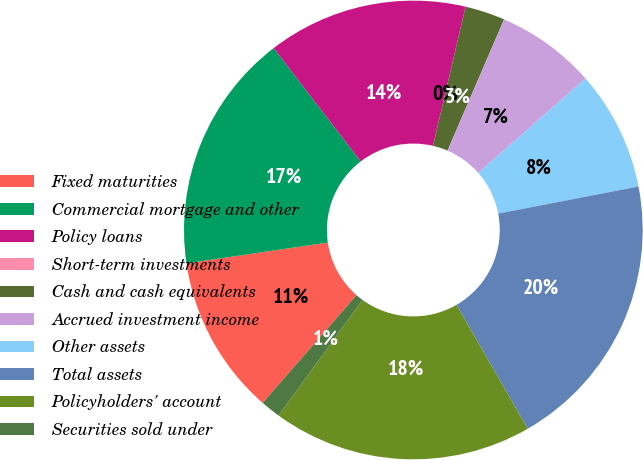Convert chart to OTSL. <chart><loc_0><loc_0><loc_500><loc_500><pie_chart><fcel>Fixed maturities<fcel>Commercial mortgage and other<fcel>Policy loans<fcel>Short-term investments<fcel>Cash and cash equivalents<fcel>Accrued investment income<fcel>Other assets<fcel>Total assets<fcel>Policyholders' account<fcel>Securities sold under<nl><fcel>11.27%<fcel>16.9%<fcel>14.08%<fcel>0.0%<fcel>2.82%<fcel>7.04%<fcel>8.45%<fcel>19.72%<fcel>18.31%<fcel>1.41%<nl></chart> 